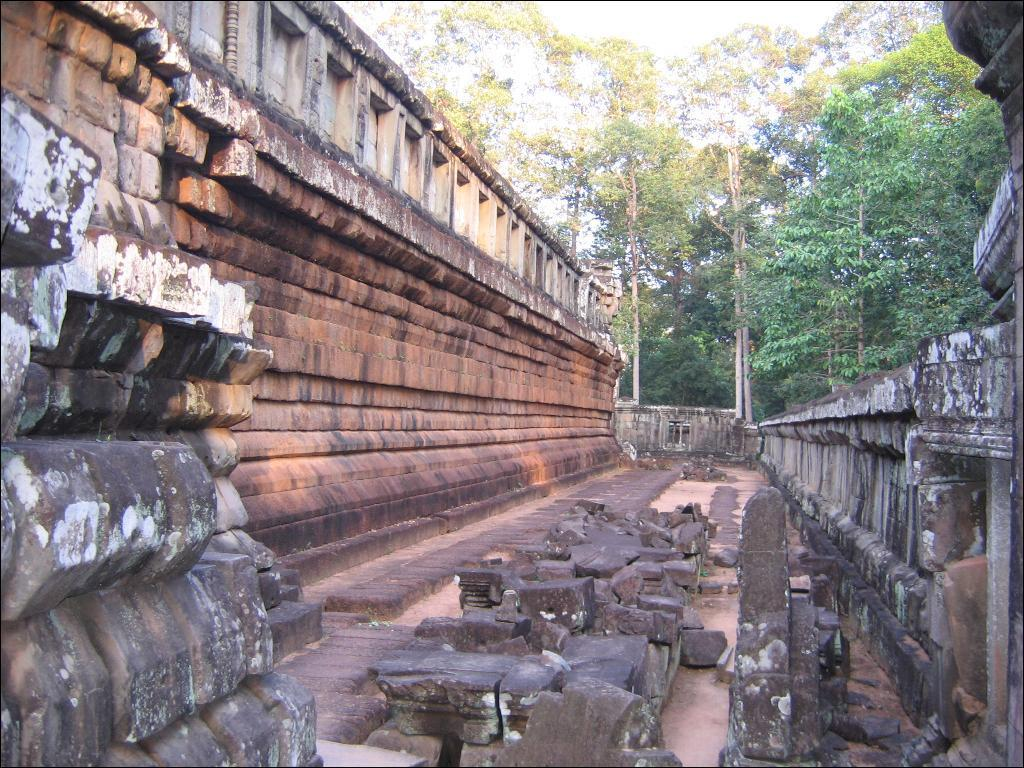What is the main activity or subject depicted in the image? The image depicts some construction. How many walls can be seen in the image? There are two walls in the image. What is present between the walls? There are broken pieces of stones between the walls. What can be seen in the background of the image? There are many trees visible in the background of the image. What type of skin condition can be seen on the trees in the image? There is no mention of a skin condition or any health issues related to the trees in the image. The trees appear to be healthy and green. 